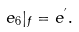Convert formula to latex. <formula><loc_0><loc_0><loc_500><loc_500>e _ { 6 } | _ { f } = e ^ { ^ { \prime } } .</formula> 